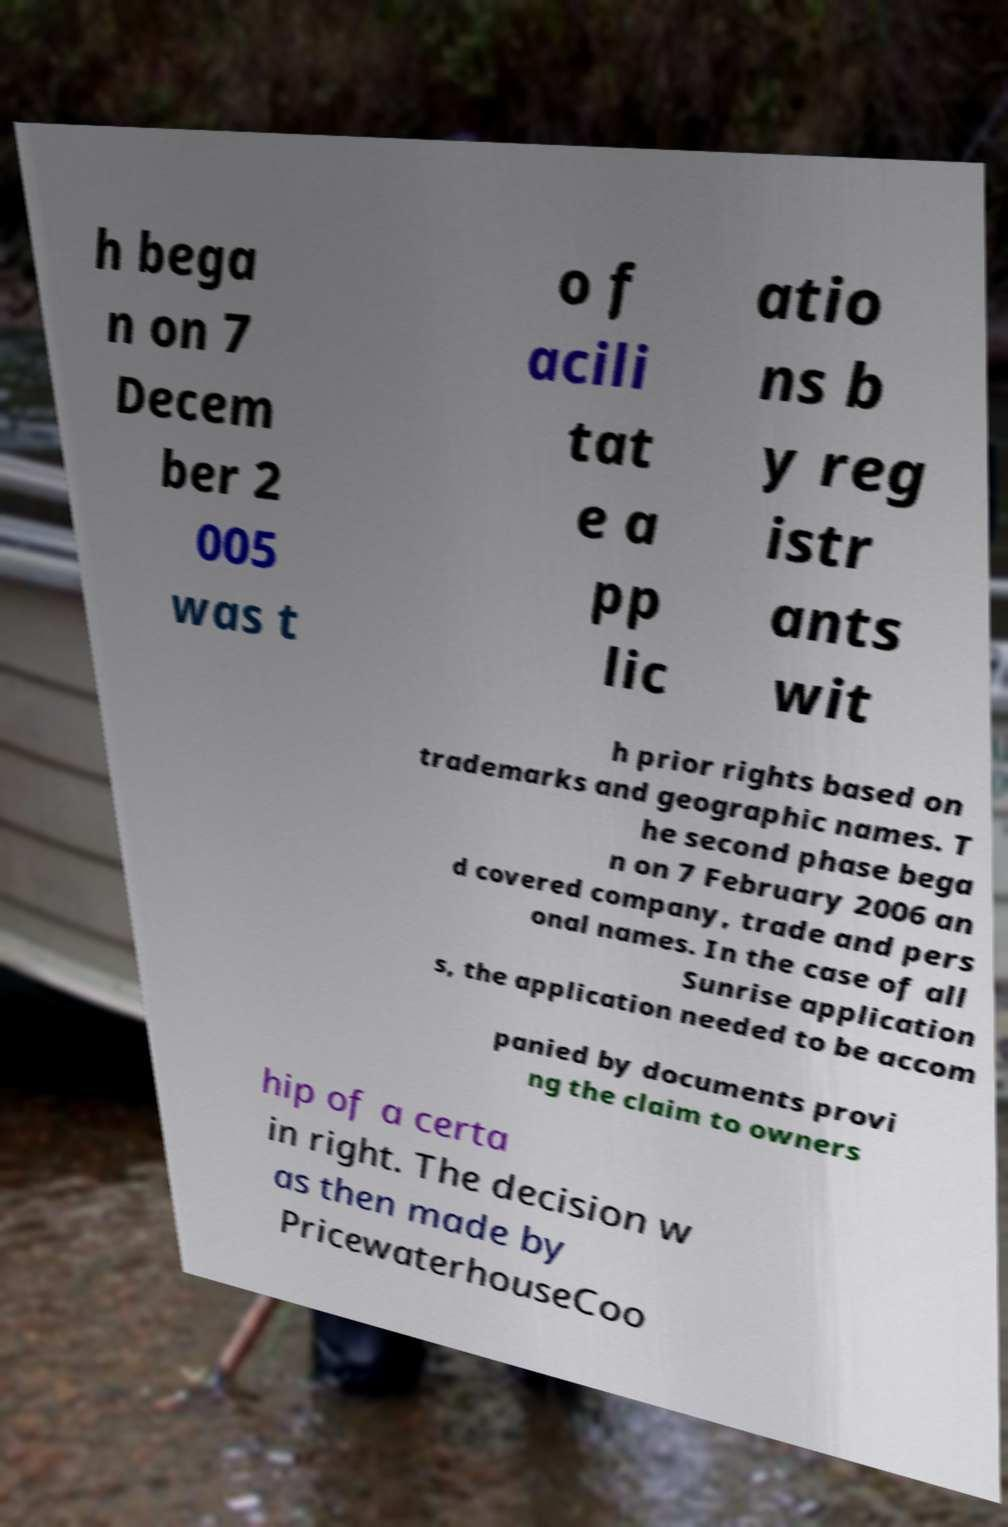Could you assist in decoding the text presented in this image and type it out clearly? h bega n on 7 Decem ber 2 005 was t o f acili tat e a pp lic atio ns b y reg istr ants wit h prior rights based on trademarks and geographic names. T he second phase bega n on 7 February 2006 an d covered company, trade and pers onal names. In the case of all Sunrise application s, the application needed to be accom panied by documents provi ng the claim to owners hip of a certa in right. The decision w as then made by PricewaterhouseCoo 